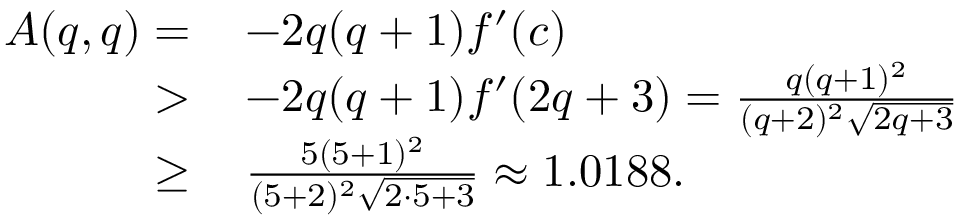<formula> <loc_0><loc_0><loc_500><loc_500>\begin{array} { r l } { A ( q , q ) = } & { \, - 2 q ( q + 1 ) f ^ { \prime } ( c ) } \\ { > } & { \, - 2 q ( q + 1 ) f ^ { \prime } ( 2 q + 3 ) = \frac { q ( q + 1 ) ^ { 2 } } { ( q + 2 ) ^ { 2 } \sqrt { 2 q + 3 } } } \\ { \geq } & { \, \frac { 5 ( 5 + 1 ) ^ { 2 } } { ( 5 + 2 ) ^ { 2 } \sqrt { 2 \cdot 5 + 3 } } \approx 1 . 0 1 8 8 . } \end{array}</formula> 